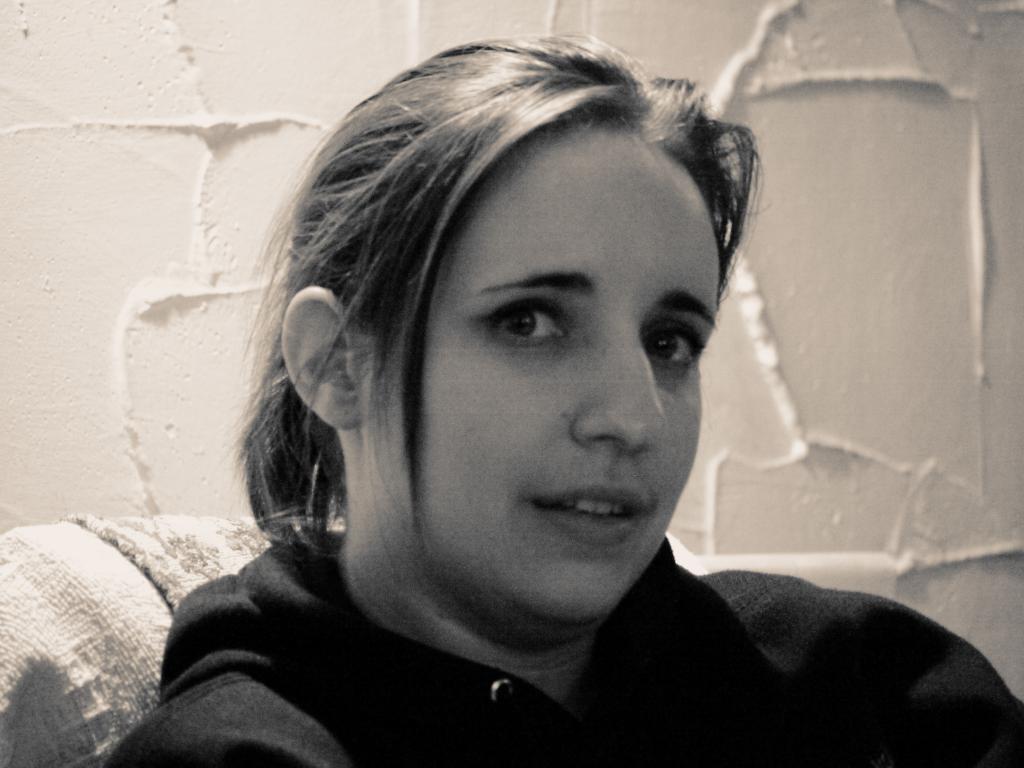Please provide a concise description of this image. In this image we can see a woman sitting on a chair and wall in the background. 